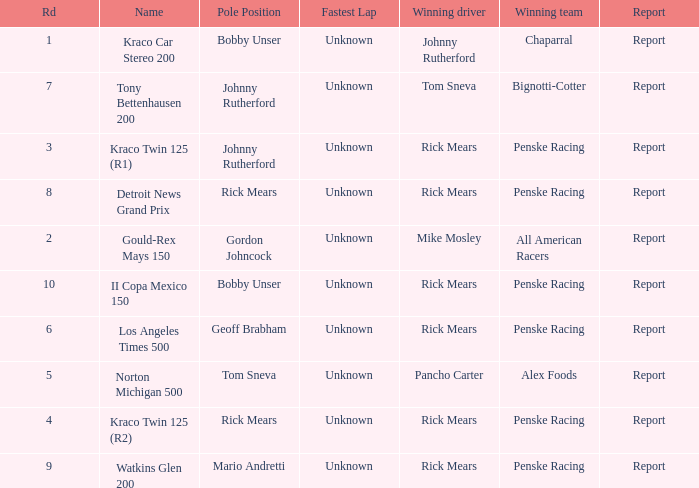The winning team of the race, los angeles times 500 is who? Penske Racing. 